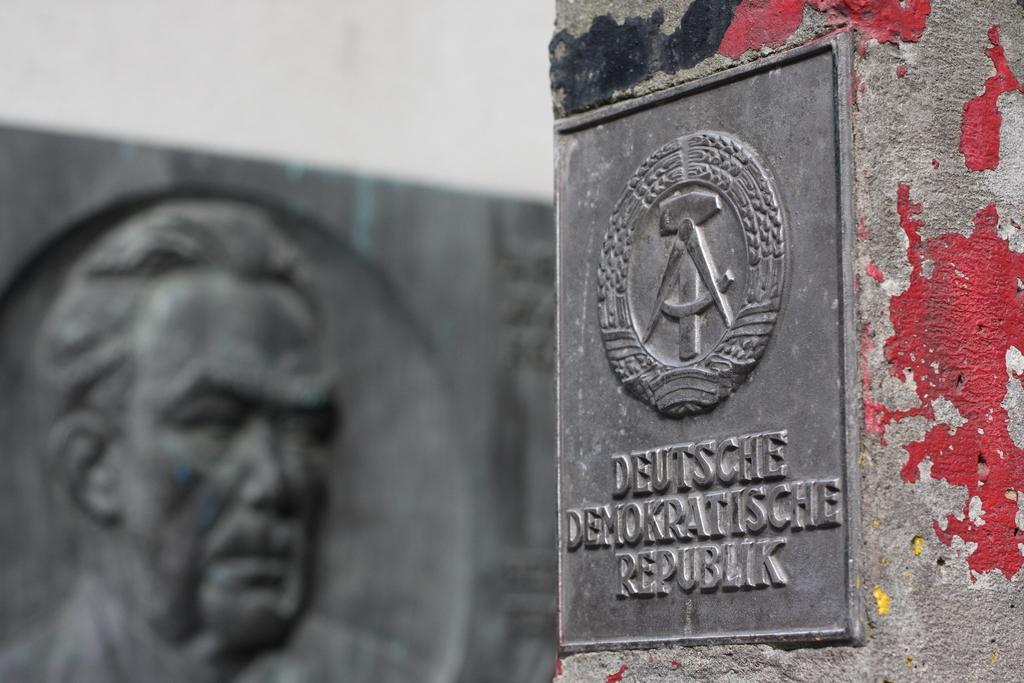Can you describe this image briefly? On the right side, there is a board, on which there is a logo and texts. This board is attached to a wall. In the background, there is a sculpture. And the background is blurred. 